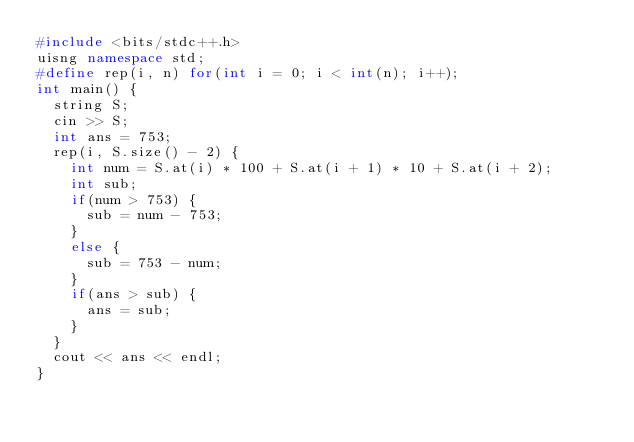<code> <loc_0><loc_0><loc_500><loc_500><_C++_>#include <bits/stdc++.h>
uisng namespace std;
#define rep(i, n) for(int i = 0; i < int(n); i++);
int main() {
  string S;
  cin >> S;
  int ans = 753;
  rep(i, S.size() - 2) {
    int num = S.at(i) * 100 + S.at(i + 1) * 10 + S.at(i + 2);
    int sub;
    if(num > 753) {
      sub = num - 753;
    }
    else {
      sub = 753 - num;
    }
    if(ans > sub) {
      ans = sub;
    }
  }
  cout << ans << endl;
}</code> 